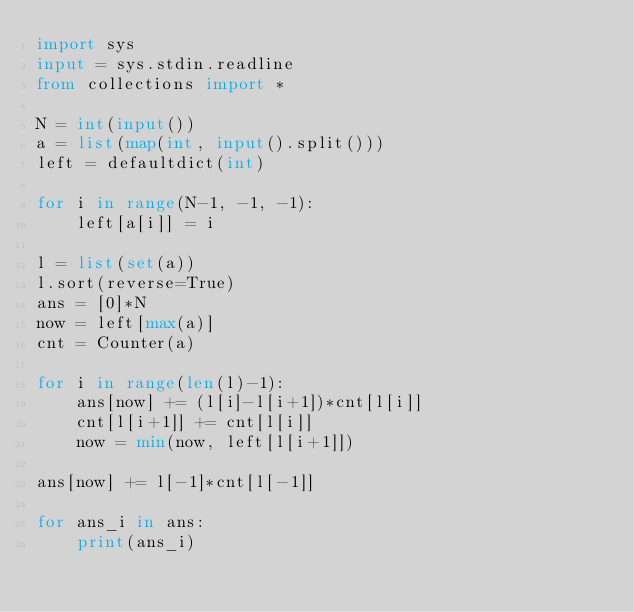Convert code to text. <code><loc_0><loc_0><loc_500><loc_500><_Python_>import sys
input = sys.stdin.readline
from collections import *

N = int(input())
a = list(map(int, input().split()))
left = defaultdict(int)

for i in range(N-1, -1, -1):
    left[a[i]] = i

l = list(set(a))
l.sort(reverse=True)
ans = [0]*N
now = left[max(a)]
cnt = Counter(a)

for i in range(len(l)-1):
    ans[now] += (l[i]-l[i+1])*cnt[l[i]]
    cnt[l[i+1]] += cnt[l[i]]
    now = min(now, left[l[i+1]])

ans[now] += l[-1]*cnt[l[-1]]

for ans_i in ans:
    print(ans_i)</code> 